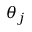Convert formula to latex. <formula><loc_0><loc_0><loc_500><loc_500>\theta _ { j }</formula> 